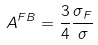<formula> <loc_0><loc_0><loc_500><loc_500>A ^ { F B } = \frac { 3 } { 4 } \frac { \sigma _ { F } } { \sigma }</formula> 